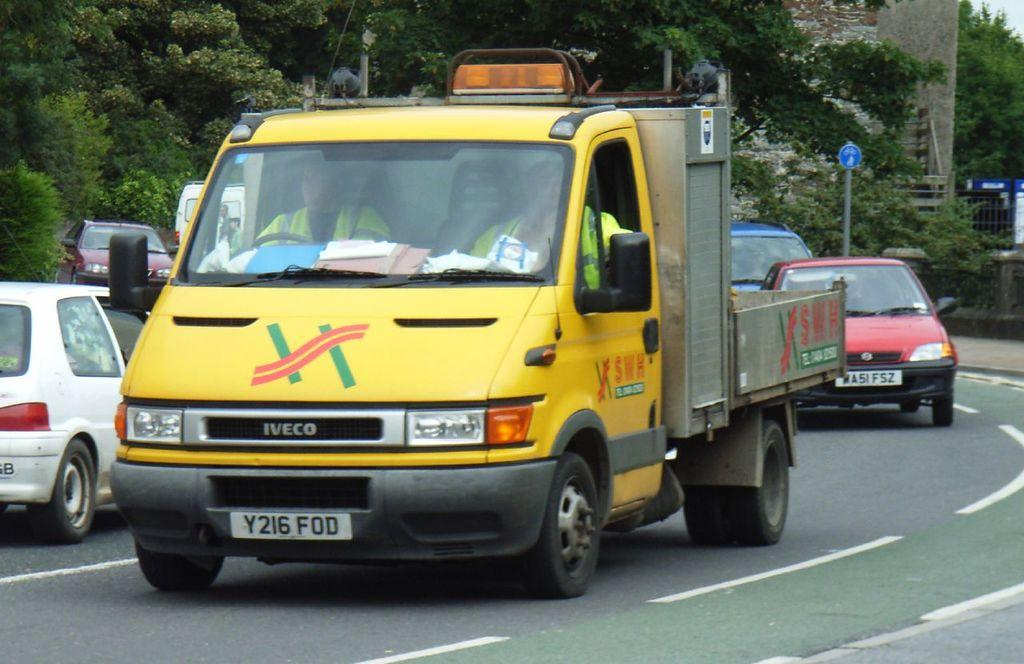What can be seen on the road in the image? There are vehicles on the road in the image. What type of natural elements are visible in the image? There are trees visible in the image. What type of man-made structure is present in the image? There is a signboard in the image. What type of barrier can be seen in the image? There is fencing in the image. What type of vertical structure is present in the image? There is a pole in the image. What type of solid structure is visible in the image? There is a wall visible in the image. What type of disgusting apparel is being worn by the mine in the image? There is no mine or apparel present in the image. What type of mine is visible in the image? There is no mine present in the image. 